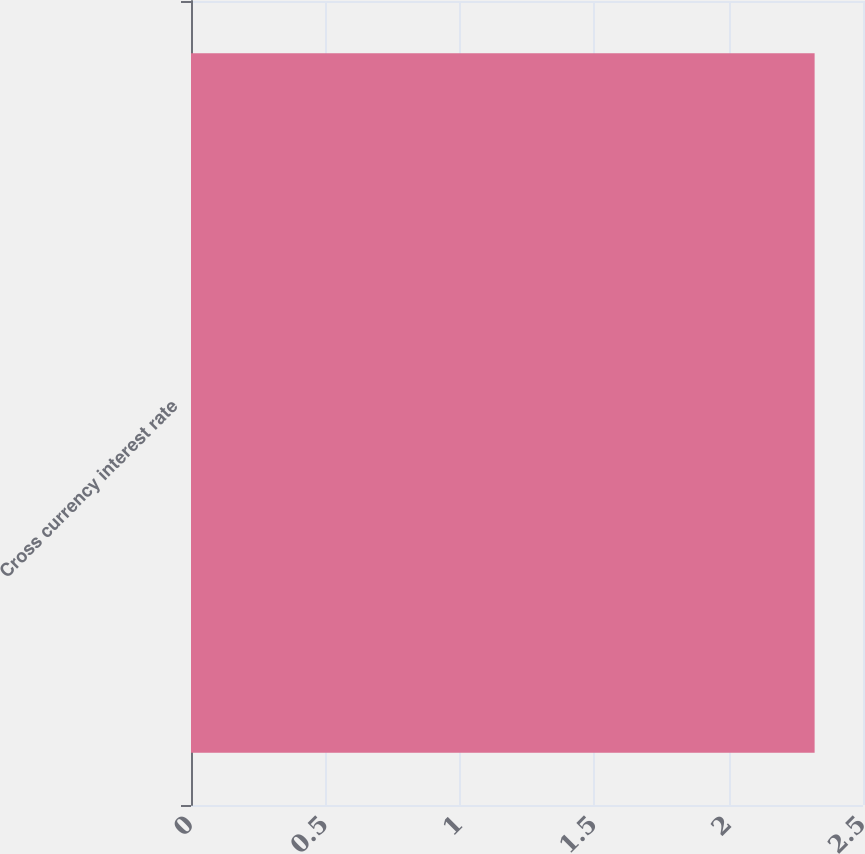Convert chart to OTSL. <chart><loc_0><loc_0><loc_500><loc_500><bar_chart><fcel>Cross currency interest rate<nl><fcel>2.32<nl></chart> 